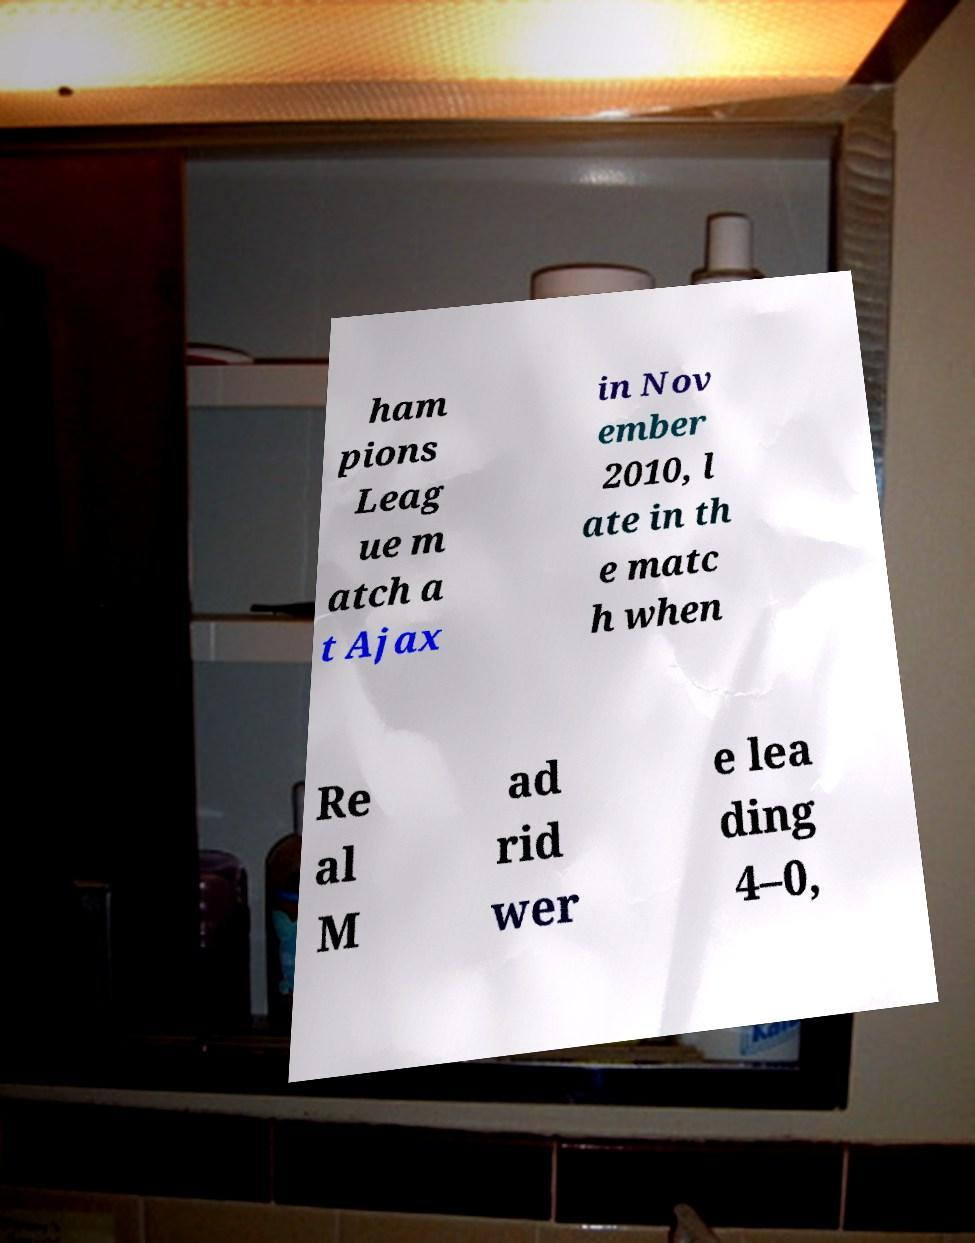Could you assist in decoding the text presented in this image and type it out clearly? ham pions Leag ue m atch a t Ajax in Nov ember 2010, l ate in th e matc h when Re al M ad rid wer e lea ding 4–0, 